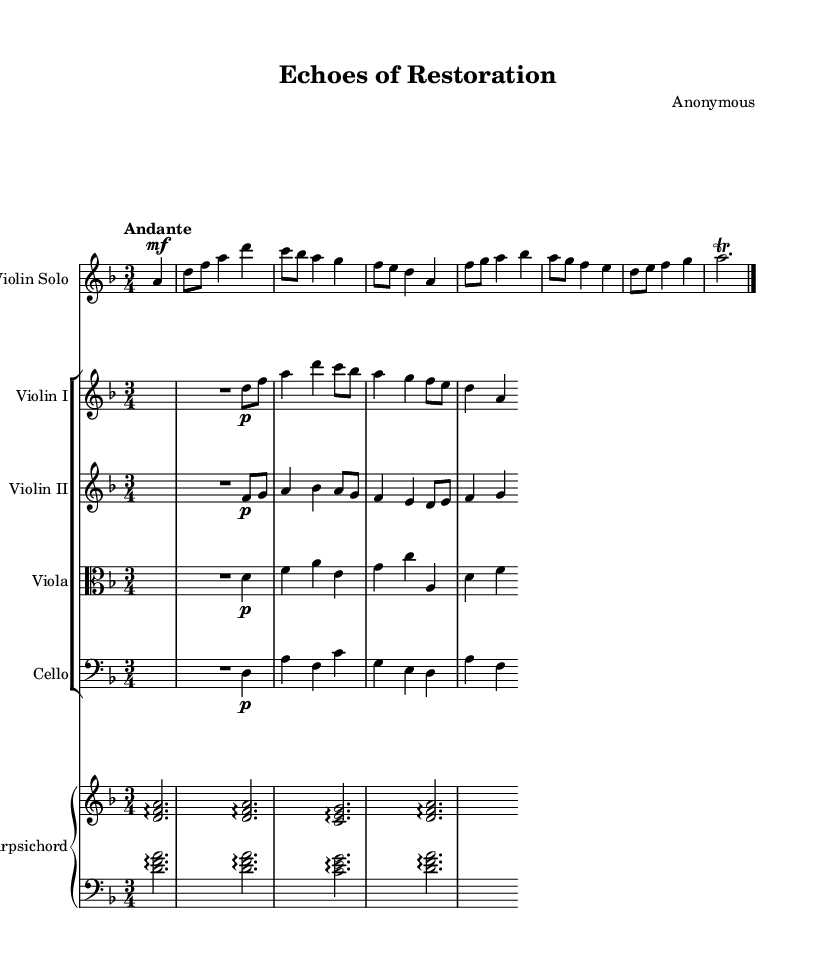What is the key signature of this music? The key signature is D minor, which has one flat (B flat). This can be found at the beginning of the first staff, right after the treble clef symbol.
Answer: D minor What is the time signature of this piece? The time signature is 3/4, indicating three beats per measure with a quarter note receiving one beat. This is displayed next to the key signature at the beginning of the score.
Answer: 3/4 What is the tempo marking of this section? The tempo marking is Andante, which suggests a moderately slow tempo. It is indicated right above the first measure after the time signature.
Answer: Andante How many instruments are featured in this concerto? There are five instruments: Violin Solo, Violin I, Violin II, Viola, Cello, and Harpsichord. This can be determined by counting each staff designated in the score.
Answer: Five Which instrument plays the main melody? The Violin Solo plays the main melody, as indicated by its prominent position in the first staff, distinctly separate from the accompaniment.
Answer: Violin Solo Which part has the lowest pitch range? The Cello part has the lowest pitch range, as it is written in the bass clef and plays notes that are lower than those of the other instruments.
Answer: Cello In what style is the music composed? The music is composed in the Baroque style, characterized by its ornamentation, contrast between solo and ensemble, and use of a figured bass in the harpsichord part.
Answer: Baroque 